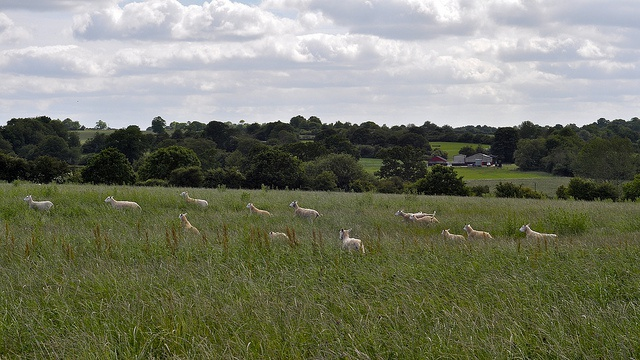Describe the objects in this image and their specific colors. I can see sheep in darkgray, gray, darkgreen, and lightgray tones, sheep in darkgray, gray, and darkgreen tones, sheep in darkgray, gray, and darkgreen tones, sheep in darkgray and gray tones, and sheep in darkgray, gray, and darkgreen tones in this image. 